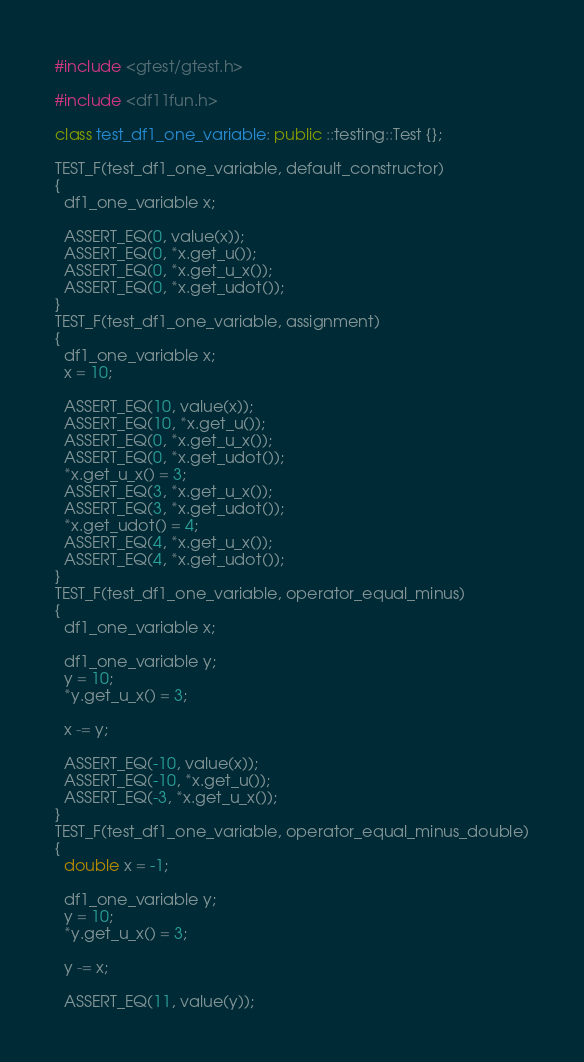<code> <loc_0><loc_0><loc_500><loc_500><_C++_>#include <gtest/gtest.h>

#include <df11fun.h>

class test_df1_one_variable: public ::testing::Test {};

TEST_F(test_df1_one_variable, default_constructor)
{
  df1_one_variable x;
  
  ASSERT_EQ(0, value(x));
  ASSERT_EQ(0, *x.get_u());
  ASSERT_EQ(0, *x.get_u_x());
  ASSERT_EQ(0, *x.get_udot());
}
TEST_F(test_df1_one_variable, assignment)
{
  df1_one_variable x;
  x = 10;
  
  ASSERT_EQ(10, value(x));
  ASSERT_EQ(10, *x.get_u());
  ASSERT_EQ(0, *x.get_u_x());
  ASSERT_EQ(0, *x.get_udot());
  *x.get_u_x() = 3;
  ASSERT_EQ(3, *x.get_u_x());
  ASSERT_EQ(3, *x.get_udot());
  *x.get_udot() = 4;
  ASSERT_EQ(4, *x.get_u_x());
  ASSERT_EQ(4, *x.get_udot());
}
TEST_F(test_df1_one_variable, operator_equal_minus)
{
  df1_one_variable x;

  df1_one_variable y;
  y = 10;
  *y.get_u_x() = 3;

  x -= y;

  ASSERT_EQ(-10, value(x));
  ASSERT_EQ(-10, *x.get_u());
  ASSERT_EQ(-3, *x.get_u_x());
}
TEST_F(test_df1_one_variable, operator_equal_minus_double)
{
  double x = -1;

  df1_one_variable y;
  y = 10;
  *y.get_u_x() = 3;

  y -= x;

  ASSERT_EQ(11, value(y));</code> 